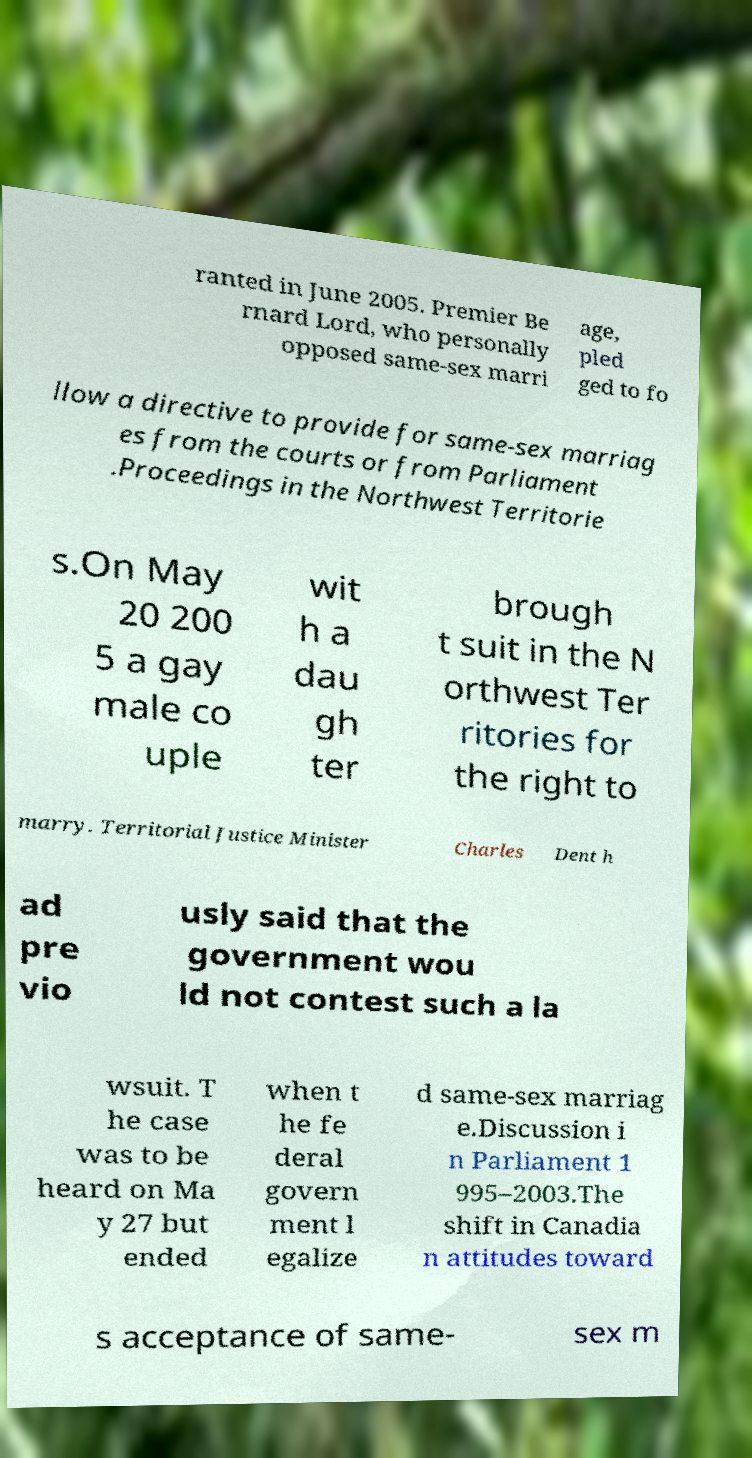I need the written content from this picture converted into text. Can you do that? ranted in June 2005. Premier Be rnard Lord, who personally opposed same-sex marri age, pled ged to fo llow a directive to provide for same-sex marriag es from the courts or from Parliament .Proceedings in the Northwest Territorie s.On May 20 200 5 a gay male co uple wit h a dau gh ter brough t suit in the N orthwest Ter ritories for the right to marry. Territorial Justice Minister Charles Dent h ad pre vio usly said that the government wou ld not contest such a la wsuit. T he case was to be heard on Ma y 27 but ended when t he fe deral govern ment l egalize d same-sex marriag e.Discussion i n Parliament 1 995–2003.The shift in Canadia n attitudes toward s acceptance of same- sex m 